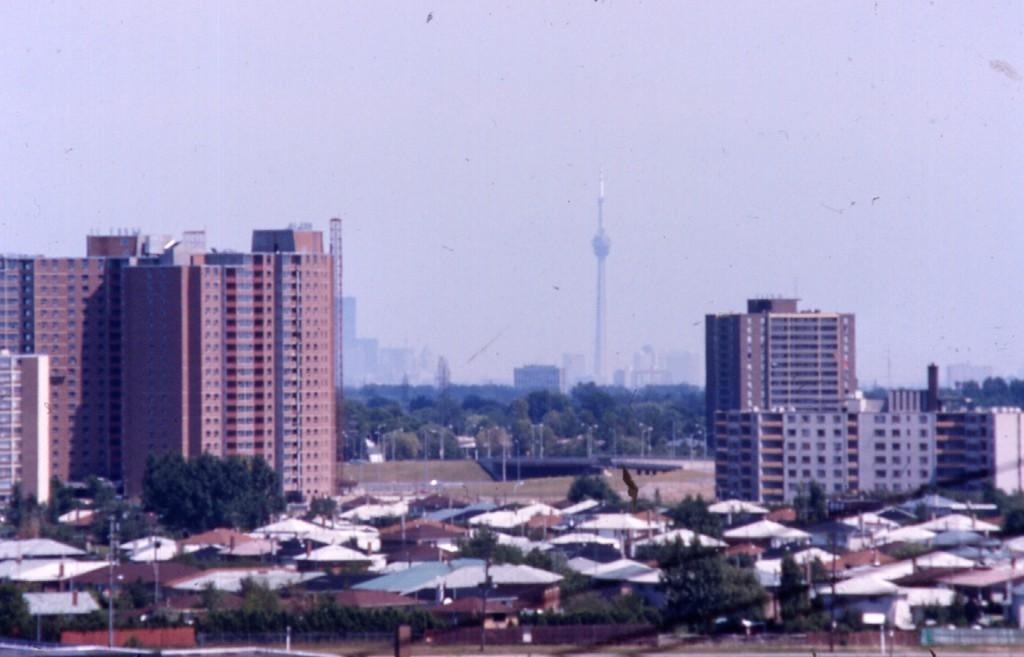What structures are located in the center of the image? There are houses and buildings in the center of the image. What type of natural elements can be seen in the background of the image? There are trees in the background of the image. What tall structure is present in the image? There is a tower in the image. What is visible at the top of the image? The sky is visible at the top of the image. Can you see the ocean in the image? No, there is no ocean visible in the image. Is there a turkey walking on the road in the image? There is no road or turkey present in the image. 